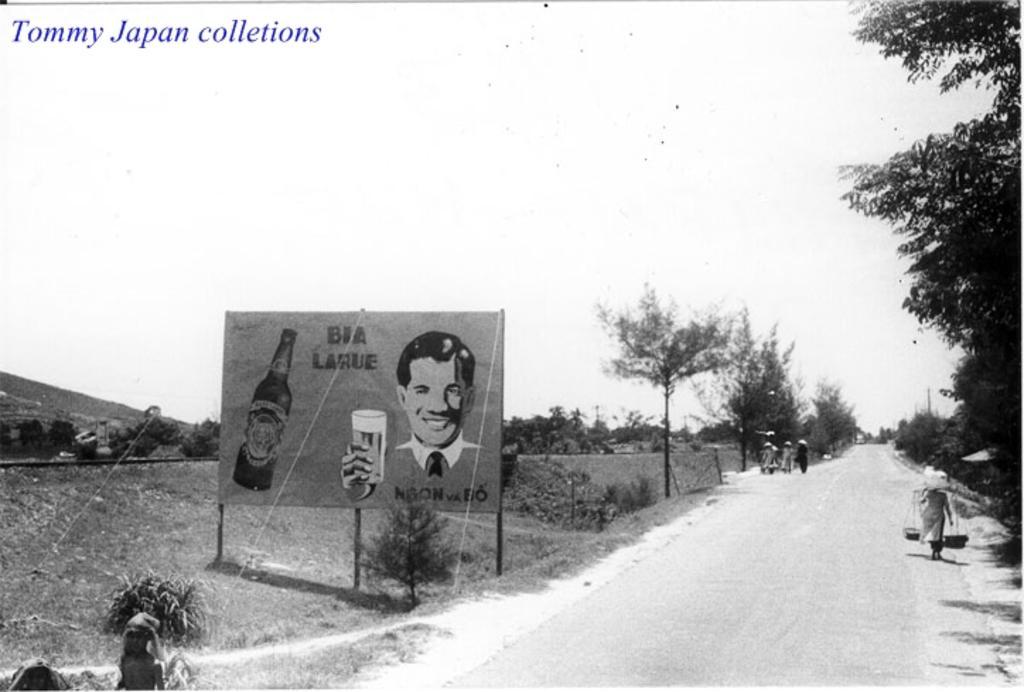Describe this image in one or two sentences. This is a black and white picture. In this picture we can see a few people on the path. We can see some people are holding objects. There is a board visible on the poles. We can see a bottle and a person holding a glass visible on this board. We can see some text on this board. There are a few plants and trees visible in the background. There is some text visible in the top left. 